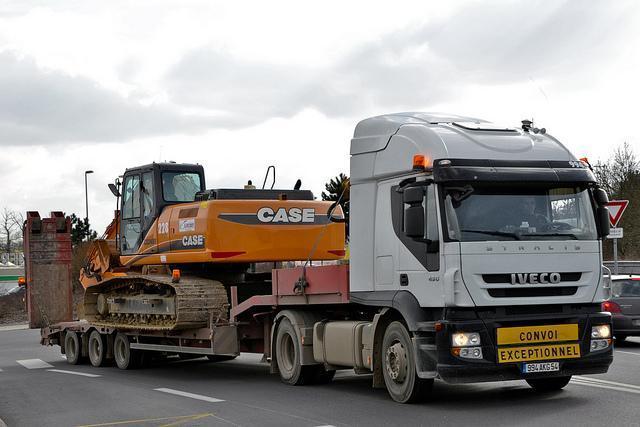How many trucks are in the photo?
Give a very brief answer. 1. 